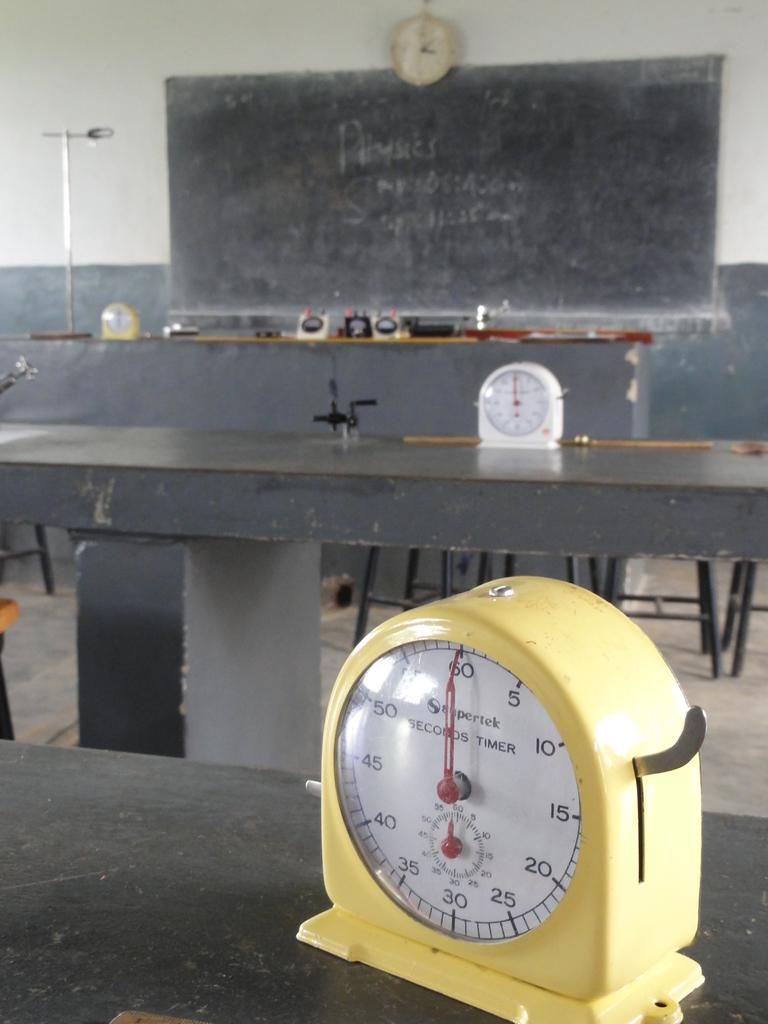<image>
Provide a brief description of the given image. In a room with a blackboard on one wall sit two SECONDS TIMERs, each with their dials set at the 60/0 mark. 